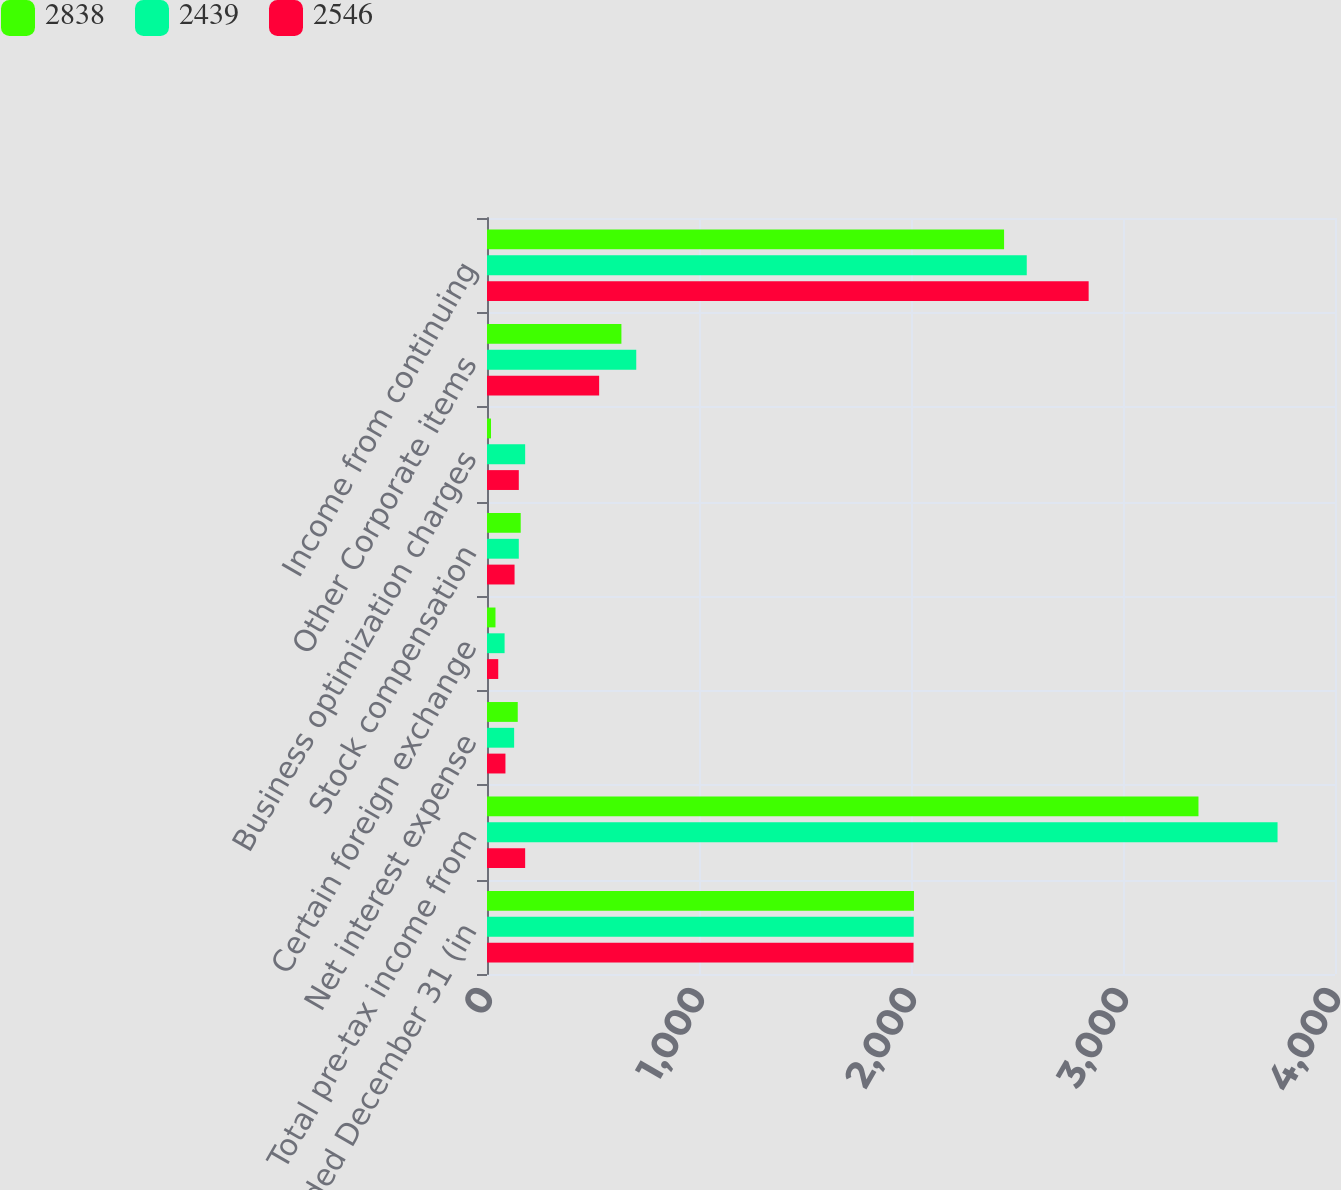Convert chart to OTSL. <chart><loc_0><loc_0><loc_500><loc_500><stacked_bar_chart><ecel><fcel>years ended December 31 (in<fcel>Total pre-tax income from<fcel>Net interest expense<fcel>Certain foreign exchange<fcel>Stock compensation<fcel>Business optimization charges<fcel>Other Corporate items<fcel>Income from continuing<nl><fcel>2838<fcel>2014<fcel>3356<fcel>145<fcel>40<fcel>159<fcel>19<fcel>634<fcel>2439<nl><fcel>2439<fcel>2013<fcel>3729<fcel>128<fcel>83<fcel>150<fcel>180<fcel>704<fcel>2546<nl><fcel>2546<fcel>2012<fcel>180<fcel>87<fcel>53<fcel>130<fcel>150<fcel>529<fcel>2838<nl></chart> 